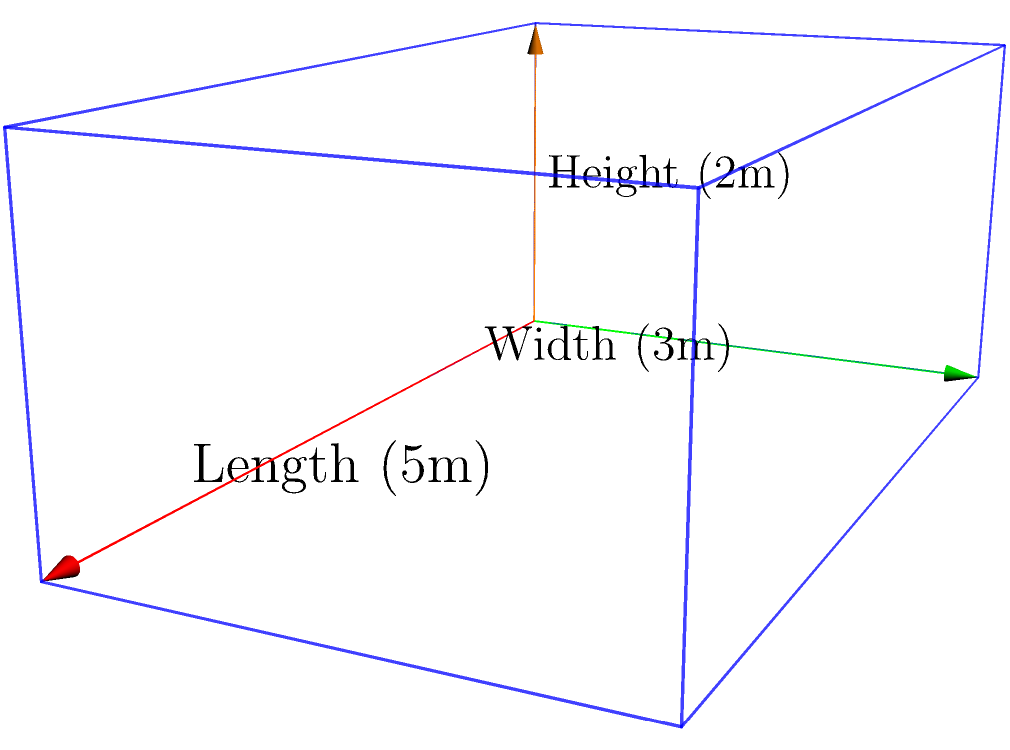As part of a water storage project in a rural village, you need to calculate the volume of a rectangular water tank. The tank's dimensions are 5 meters in length, 3 meters in width, and 2 meters in height. What is the total volume of water this tank can hold in cubic meters? To calculate the volume of a rectangular tank, we use the formula:

$$V = l \times w \times h$$

Where:
$V$ = Volume
$l$ = Length
$w$ = Width
$h$ = Height

Given the dimensions:
$l = 5$ meters
$w = 3$ meters
$h = 2$ meters

Let's substitute these values into the formula:

$$V = 5 \times 3 \times 2$$

Now, let's perform the multiplication:

$$V = 30$$

Therefore, the volume of the water tank is 30 cubic meters.
Answer: 30 m³ 